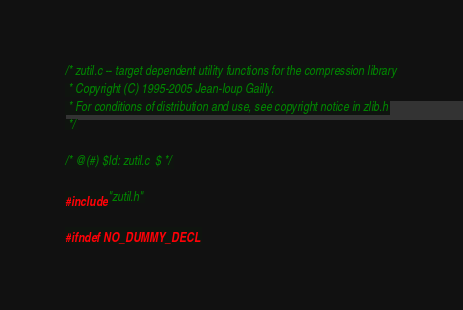<code> <loc_0><loc_0><loc_500><loc_500><_C_>/* zutil.c -- target dependent utility functions for the compression library
 * Copyright (C) 1995-2005 Jean-loup Gailly.
 * For conditions of distribution and use, see copyright notice in zlib.h
 */

/* @(#) $Id: zutil.c  $ */

#include "zutil.h"

#ifndef NO_DUMMY_DECL</code> 